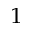Convert formula to latex. <formula><loc_0><loc_0><loc_500><loc_500>^ { 1 }</formula> 